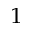Convert formula to latex. <formula><loc_0><loc_0><loc_500><loc_500>^ { 1 }</formula> 